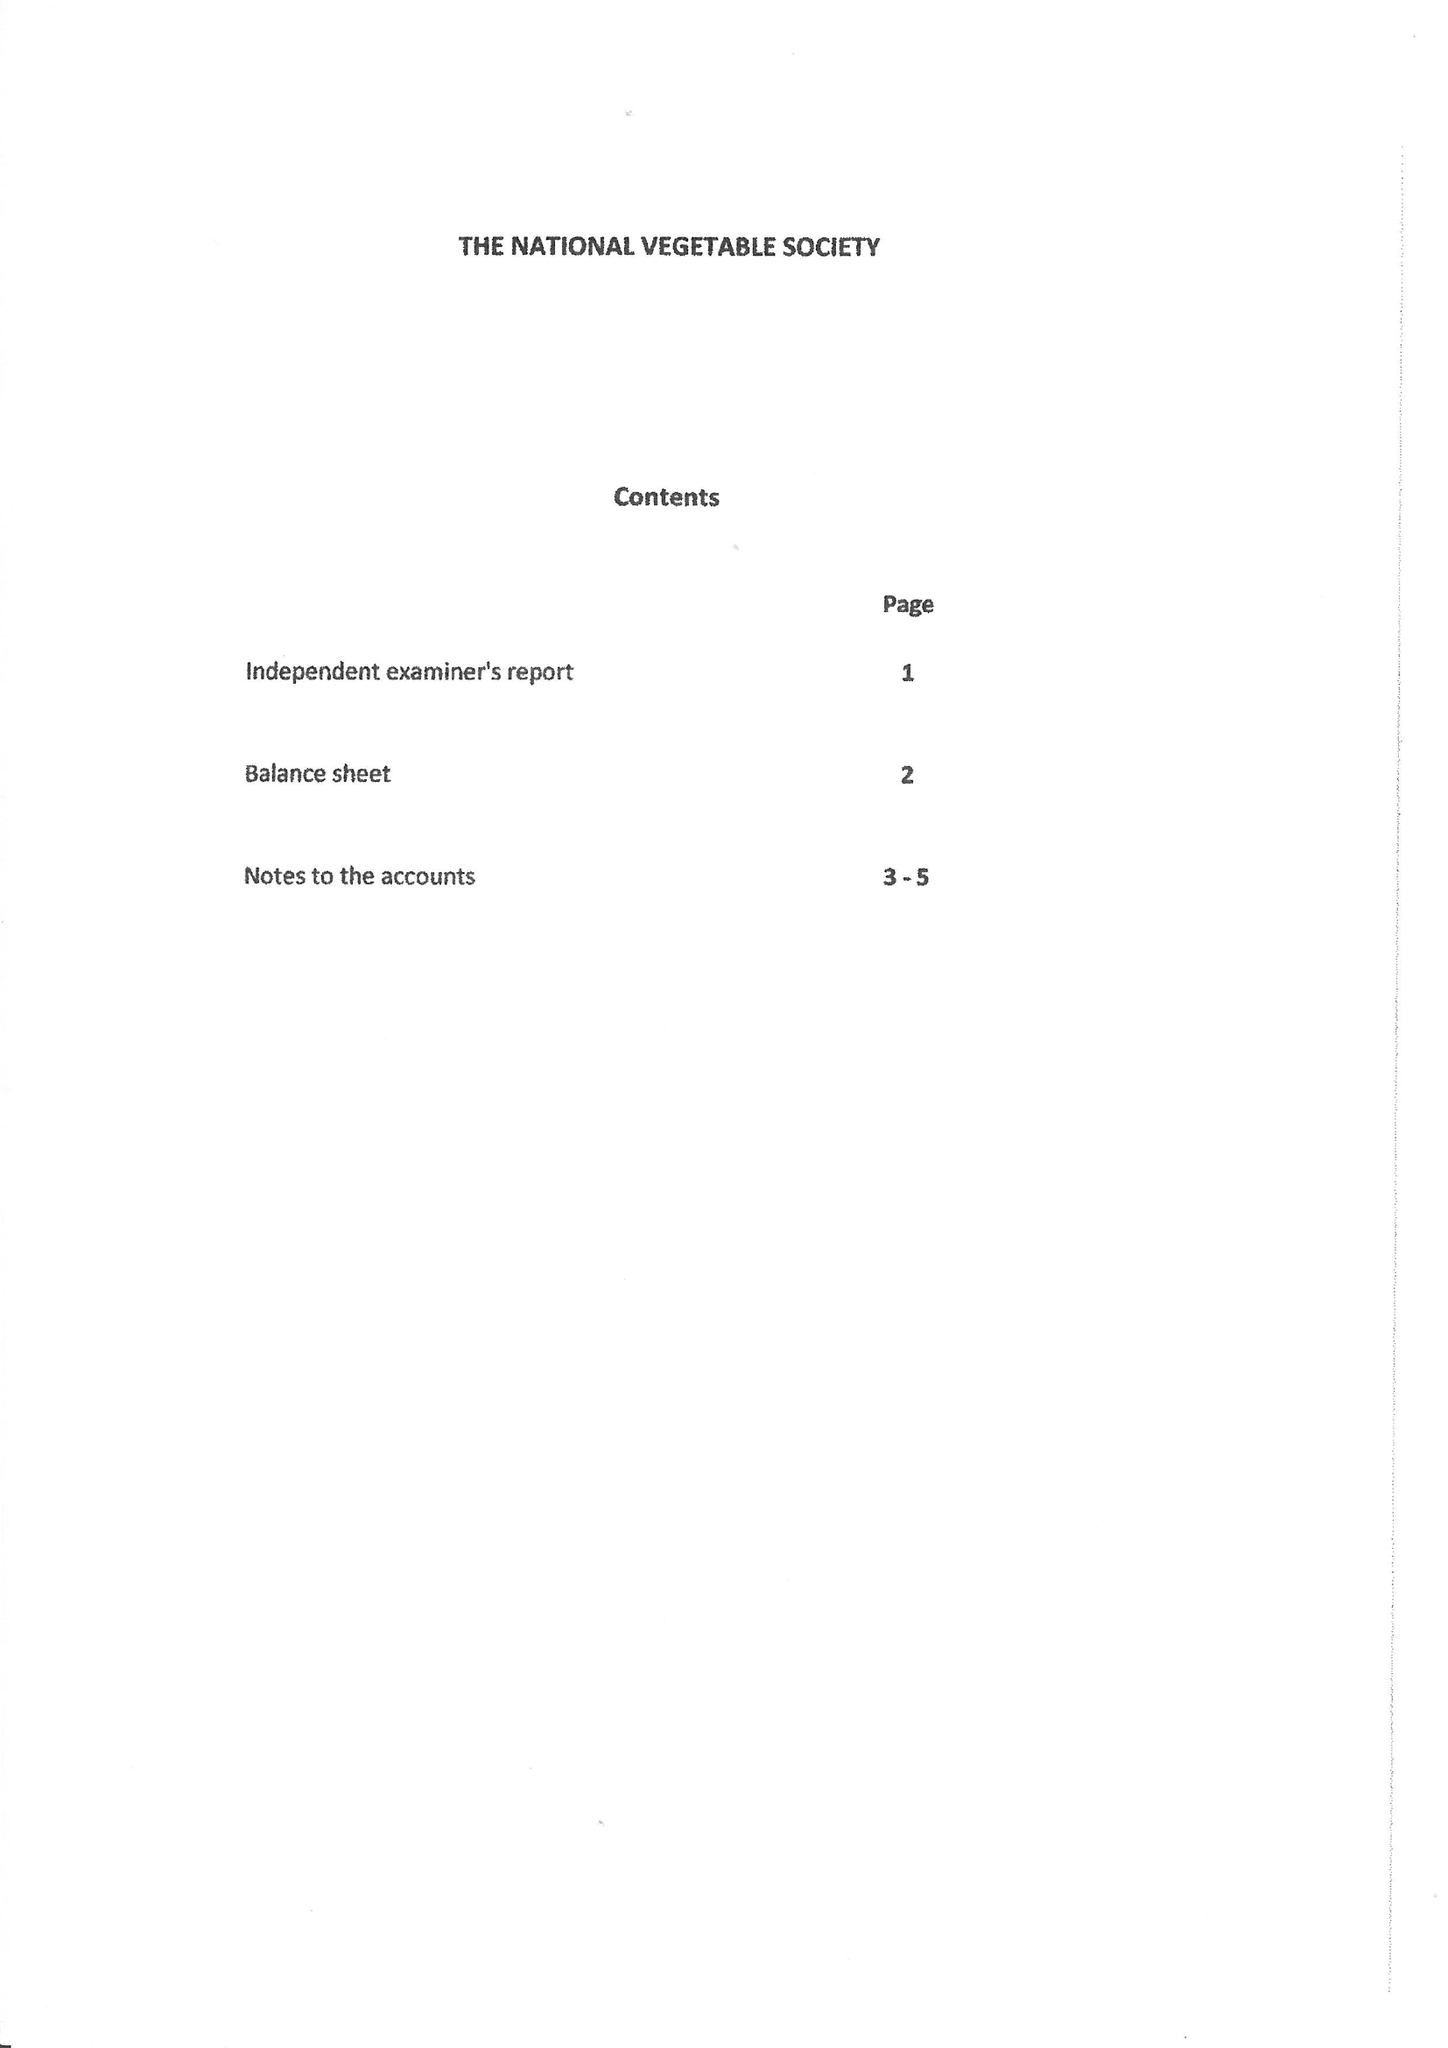What is the value for the report_date?
Answer the question using a single word or phrase. 2015-12-31 